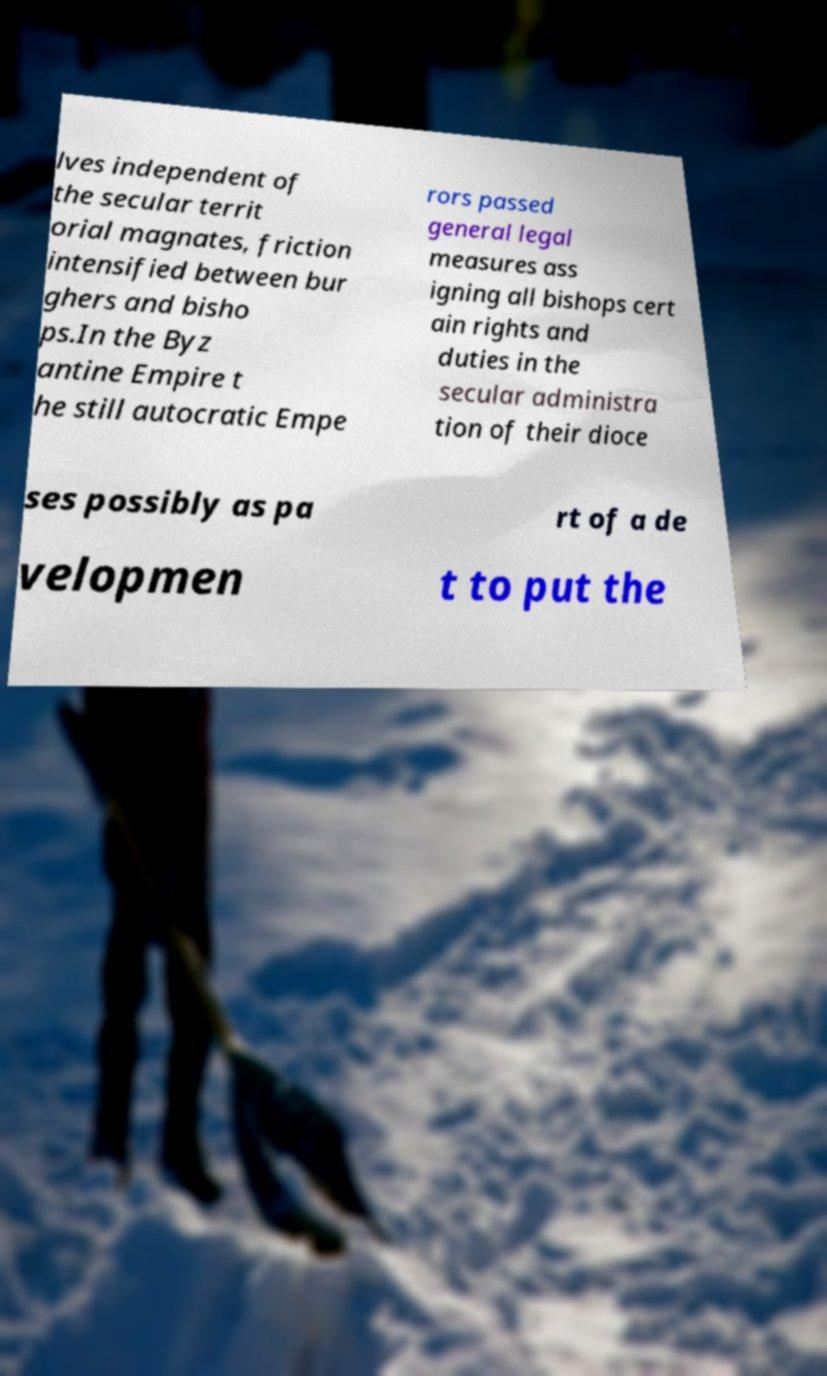Please read and relay the text visible in this image. What does it say? lves independent of the secular territ orial magnates, friction intensified between bur ghers and bisho ps.In the Byz antine Empire t he still autocratic Empe rors passed general legal measures ass igning all bishops cert ain rights and duties in the secular administra tion of their dioce ses possibly as pa rt of a de velopmen t to put the 